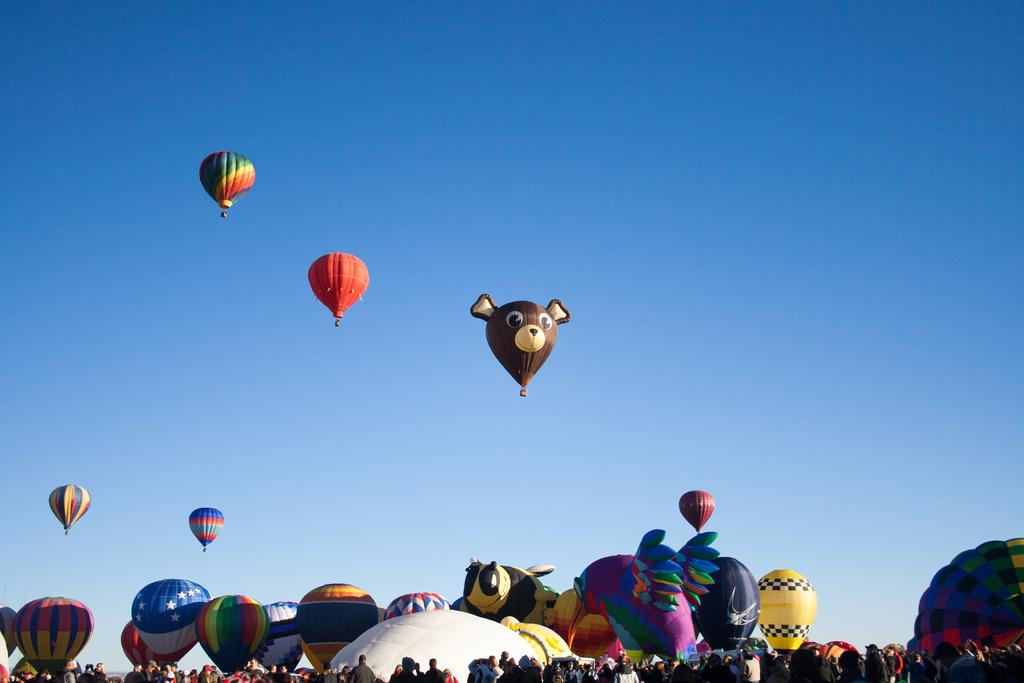What can be seen at the bottom of the image? There are people at the bottom of the image. What is located in the middle of the image? There are hot air balloons in the middle of the image. What is visible at the top of the image? The sky is visible at the top of the image. What type of ring can be seen on the hot air balloon in the image? There is no ring present on the hot air balloons in the image. What kind of voyage are the people at the bottom of the image embarking on? The image does not provide information about any voyage or journey that the people might be taking. 